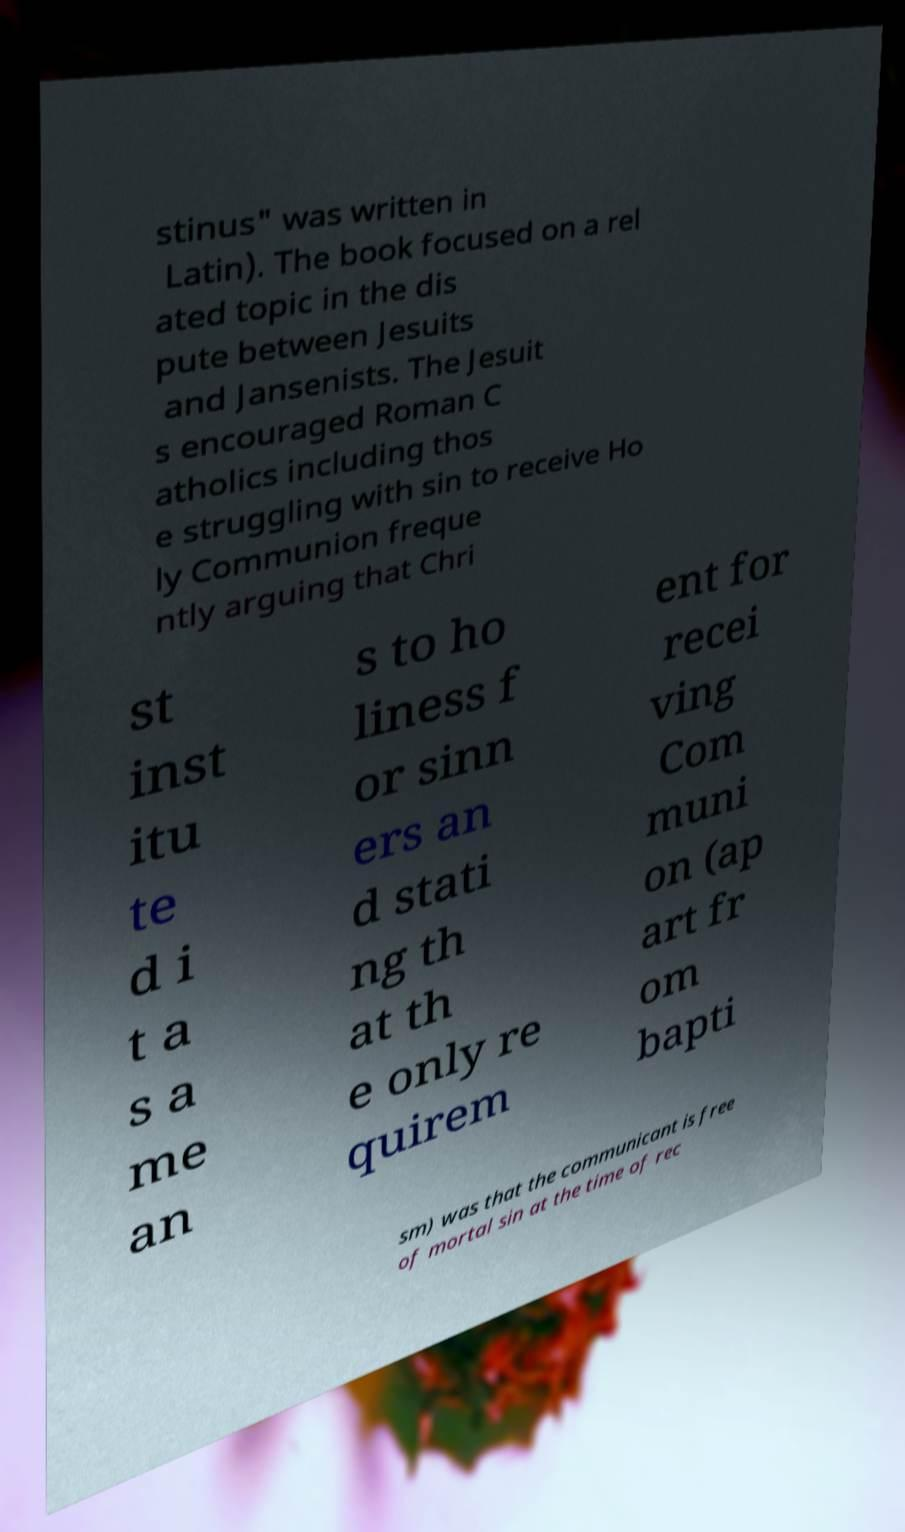Could you assist in decoding the text presented in this image and type it out clearly? stinus" was written in Latin). The book focused on a rel ated topic in the dis pute between Jesuits and Jansenists. The Jesuit s encouraged Roman C atholics including thos e struggling with sin to receive Ho ly Communion freque ntly arguing that Chri st inst itu te d i t a s a me an s to ho liness f or sinn ers an d stati ng th at th e only re quirem ent for recei ving Com muni on (ap art fr om bapti sm) was that the communicant is free of mortal sin at the time of rec 